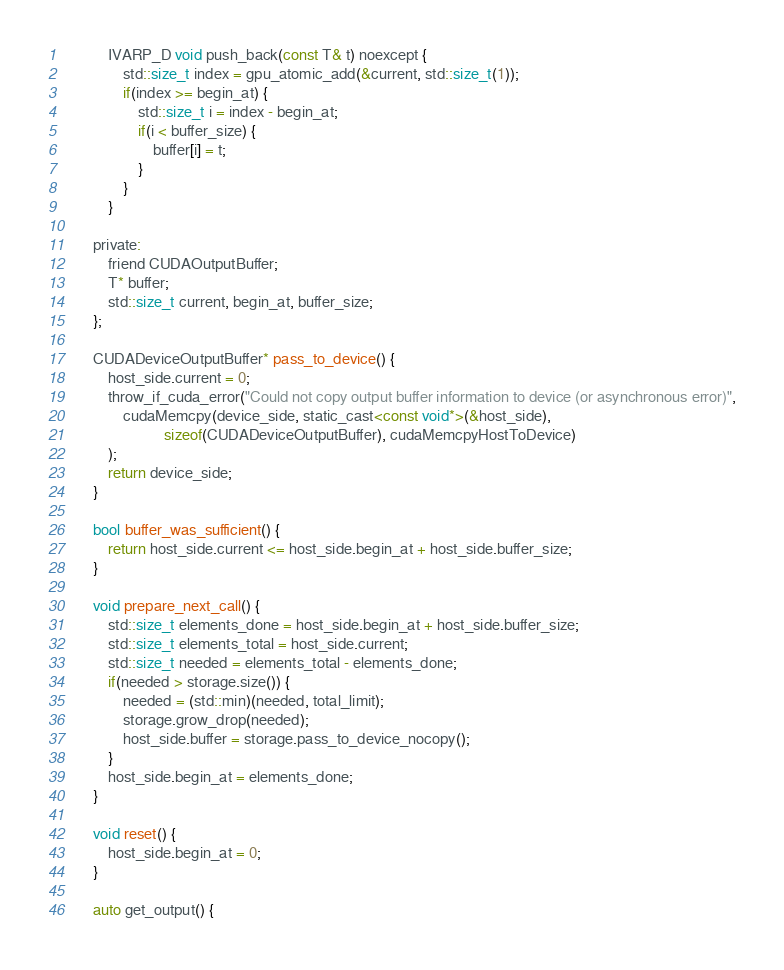Convert code to text. <code><loc_0><loc_0><loc_500><loc_500><_Cuda_>
            IVARP_D void push_back(const T& t) noexcept {
                std::size_t index = gpu_atomic_add(&current, std::size_t(1));
                if(index >= begin_at) {
                    std::size_t i = index - begin_at;
                    if(i < buffer_size) {
                        buffer[i] = t;
                    }
                }
            }

        private:
            friend CUDAOutputBuffer;
            T* buffer;
            std::size_t current, begin_at, buffer_size;
        };

        CUDADeviceOutputBuffer* pass_to_device() {
            host_side.current = 0;
            throw_if_cuda_error("Could not copy output buffer information to device (or asynchronous error)",
                cudaMemcpy(device_side, static_cast<const void*>(&host_side),
                           sizeof(CUDADeviceOutputBuffer), cudaMemcpyHostToDevice)
            );
            return device_side;
        }

        bool buffer_was_sufficient() {
            return host_side.current <= host_side.begin_at + host_side.buffer_size;
        }

        void prepare_next_call() {
            std::size_t elements_done = host_side.begin_at + host_side.buffer_size;
            std::size_t elements_total = host_side.current;
            std::size_t needed = elements_total - elements_done;
            if(needed > storage.size()) {
                needed = (std::min)(needed, total_limit);
                storage.grow_drop(needed);
                host_side.buffer = storage.pass_to_device_nocopy();
            }
            host_side.begin_at = elements_done;
        }

        void reset() {
            host_side.begin_at = 0;
        }

        auto get_output() {</code> 